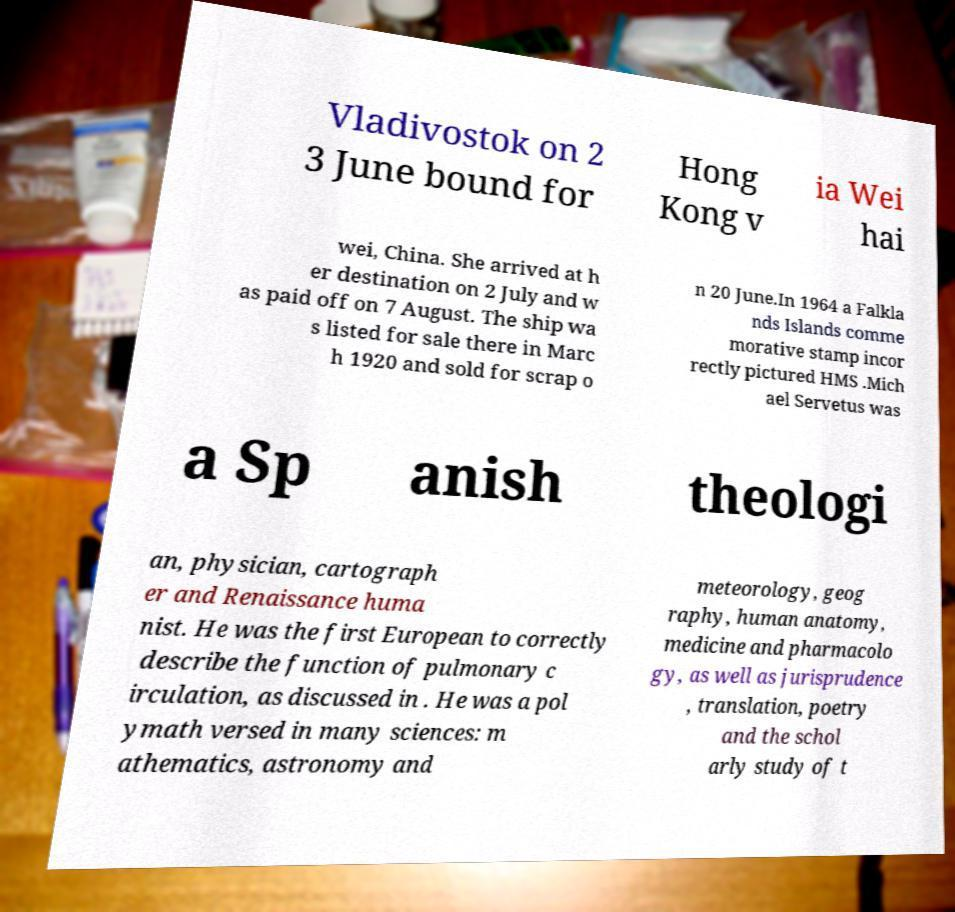Could you assist in decoding the text presented in this image and type it out clearly? Vladivostok on 2 3 June bound for Hong Kong v ia Wei hai wei, China. She arrived at h er destination on 2 July and w as paid off on 7 August. The ship wa s listed for sale there in Marc h 1920 and sold for scrap o n 20 June.In 1964 a Falkla nds Islands comme morative stamp incor rectly pictured HMS .Mich ael Servetus was a Sp anish theologi an, physician, cartograph er and Renaissance huma nist. He was the first European to correctly describe the function of pulmonary c irculation, as discussed in . He was a pol ymath versed in many sciences: m athematics, astronomy and meteorology, geog raphy, human anatomy, medicine and pharmacolo gy, as well as jurisprudence , translation, poetry and the schol arly study of t 